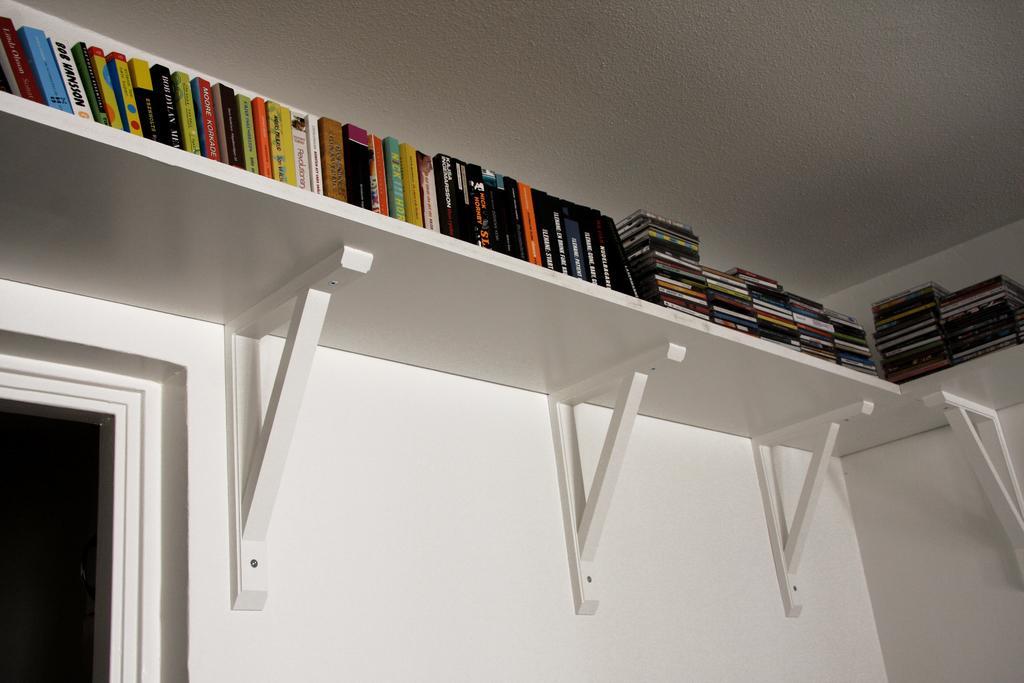Can you describe this image briefly? In this image I can see number of books on the racks. I can also see black color on the bottom left side. 